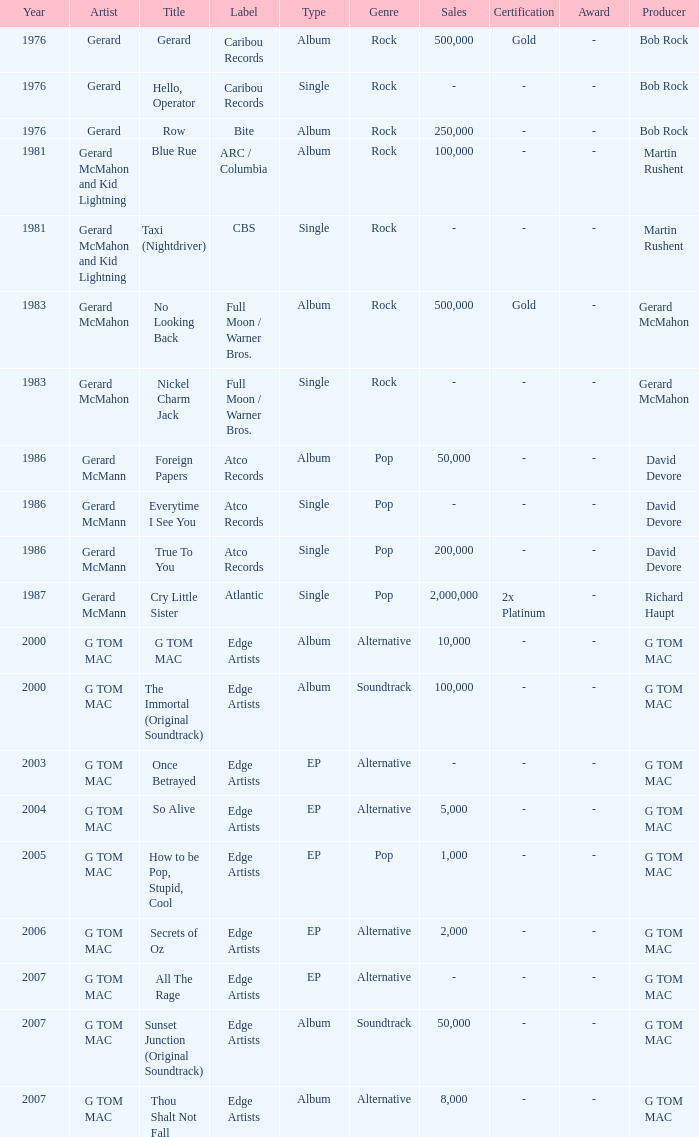Which Title has a Type of album in 1983? No Looking Back. 